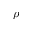Convert formula to latex. <formula><loc_0><loc_0><loc_500><loc_500>\rho</formula> 